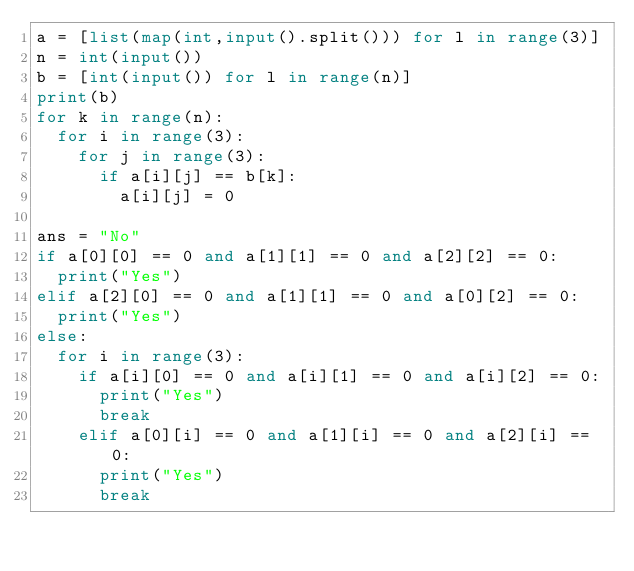Convert code to text. <code><loc_0><loc_0><loc_500><loc_500><_Python_>a = [list(map(int,input().split())) for l in range(3)]
n = int(input())
b = [int(input()) for l in range(n)]
print(b)
for k in range(n):
  for i in range(3):
    for j in range(3):
      if a[i][j] == b[k]:
        a[i][j] = 0

ans = "No"
if a[0][0] == 0 and a[1][1] == 0 and a[2][2] == 0:
  print("Yes")
elif a[2][0] == 0 and a[1][1] == 0 and a[0][2] == 0:
  print("Yes")
else:
  for i in range(3):
    if a[i][0] == 0 and a[i][1] == 0 and a[i][2] == 0:
      print("Yes")
      break
    elif a[0][i] == 0 and a[1][i] == 0 and a[2][i] == 0:
      print("Yes")
      break


</code> 